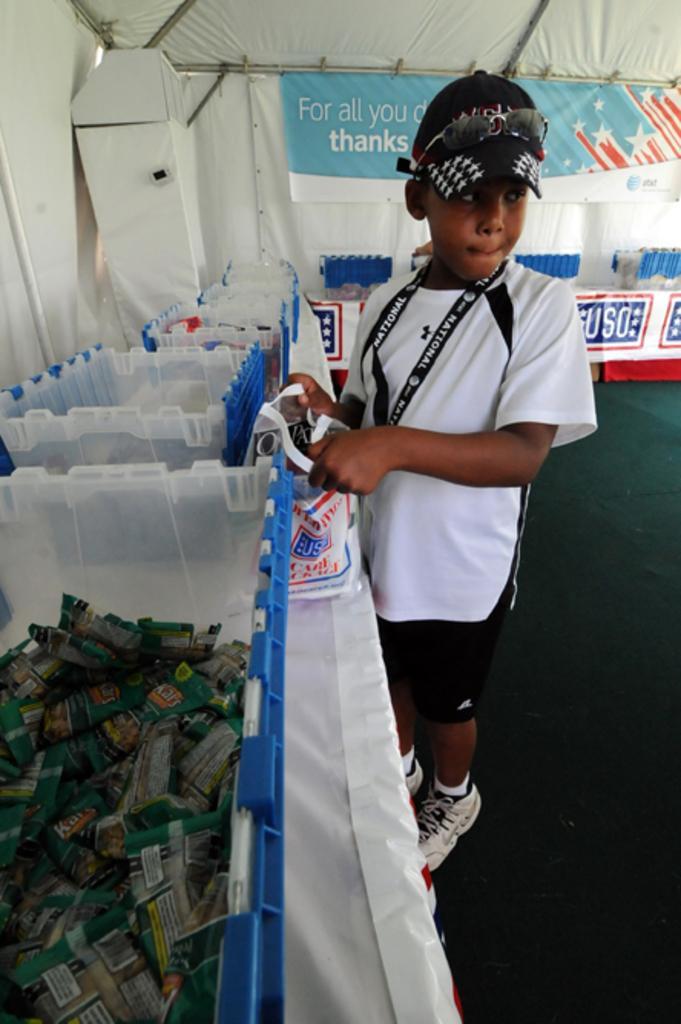Could you give a brief overview of what you see in this image? As we can see in the image there is a table on which boxes are kept and there are packet in the boxes and the kid over here is standing he is wearing a black and white shirt and shorts, white shoes and he is holding a cover. A cap on the head and goggles over it and behind him there is a banner and the ground is in green colour carpet. 